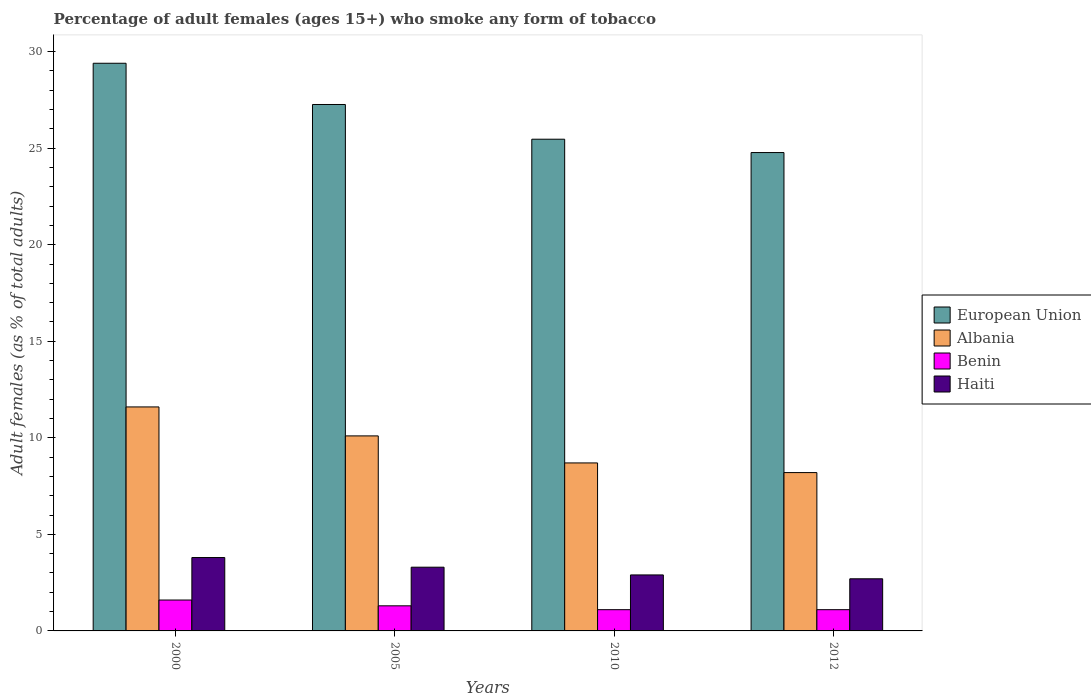Are the number of bars per tick equal to the number of legend labels?
Offer a terse response. Yes. How many bars are there on the 2nd tick from the left?
Ensure brevity in your answer.  4. What is the label of the 3rd group of bars from the left?
Offer a terse response. 2010. In how many cases, is the number of bars for a given year not equal to the number of legend labels?
Provide a short and direct response. 0. Across all years, what is the minimum percentage of adult females who smoke in Benin?
Your answer should be compact. 1.1. In which year was the percentage of adult females who smoke in Benin maximum?
Your answer should be compact. 2000. What is the total percentage of adult females who smoke in Benin in the graph?
Your answer should be compact. 5.1. What is the difference between the percentage of adult females who smoke in Benin in 2005 and that in 2012?
Ensure brevity in your answer.  0.2. What is the average percentage of adult females who smoke in Haiti per year?
Offer a terse response. 3.17. In the year 2012, what is the difference between the percentage of adult females who smoke in Haiti and percentage of adult females who smoke in Albania?
Your response must be concise. -5.5. In how many years, is the percentage of adult females who smoke in Benin greater than 25 %?
Give a very brief answer. 0. What is the ratio of the percentage of adult females who smoke in Haiti in 2000 to that in 2005?
Keep it short and to the point. 1.15. Is the percentage of adult females who smoke in Benin in 2005 less than that in 2010?
Your answer should be very brief. No. What is the difference between the highest and the second highest percentage of adult females who smoke in European Union?
Your answer should be very brief. 2.14. What is the difference between the highest and the lowest percentage of adult females who smoke in Haiti?
Your answer should be very brief. 1.1. Is the sum of the percentage of adult females who smoke in Albania in 2010 and 2012 greater than the maximum percentage of adult females who smoke in Haiti across all years?
Your response must be concise. Yes. What does the 3rd bar from the left in 2010 represents?
Your answer should be very brief. Benin. What does the 3rd bar from the right in 2012 represents?
Keep it short and to the point. Albania. How many bars are there?
Offer a very short reply. 16. Are all the bars in the graph horizontal?
Keep it short and to the point. No. What is the difference between two consecutive major ticks on the Y-axis?
Your response must be concise. 5. Does the graph contain any zero values?
Provide a succinct answer. No. Does the graph contain grids?
Ensure brevity in your answer.  No. How many legend labels are there?
Give a very brief answer. 4. What is the title of the graph?
Give a very brief answer. Percentage of adult females (ages 15+) who smoke any form of tobacco. What is the label or title of the X-axis?
Your answer should be compact. Years. What is the label or title of the Y-axis?
Make the answer very short. Adult females (as % of total adults). What is the Adult females (as % of total adults) of European Union in 2000?
Your answer should be very brief. 29.4. What is the Adult females (as % of total adults) in Haiti in 2000?
Keep it short and to the point. 3.8. What is the Adult females (as % of total adults) of European Union in 2005?
Your answer should be compact. 27.26. What is the Adult females (as % of total adults) in Benin in 2005?
Offer a terse response. 1.3. What is the Adult females (as % of total adults) in Haiti in 2005?
Make the answer very short. 3.3. What is the Adult females (as % of total adults) of European Union in 2010?
Keep it short and to the point. 25.46. What is the Adult females (as % of total adults) of Albania in 2010?
Ensure brevity in your answer.  8.7. What is the Adult females (as % of total adults) in Benin in 2010?
Give a very brief answer. 1.1. What is the Adult females (as % of total adults) in European Union in 2012?
Your answer should be compact. 24.77. What is the Adult females (as % of total adults) of Haiti in 2012?
Give a very brief answer. 2.7. Across all years, what is the maximum Adult females (as % of total adults) of European Union?
Give a very brief answer. 29.4. Across all years, what is the maximum Adult females (as % of total adults) of Albania?
Your response must be concise. 11.6. Across all years, what is the maximum Adult females (as % of total adults) of Haiti?
Provide a short and direct response. 3.8. Across all years, what is the minimum Adult females (as % of total adults) of European Union?
Keep it short and to the point. 24.77. Across all years, what is the minimum Adult females (as % of total adults) of Albania?
Keep it short and to the point. 8.2. Across all years, what is the minimum Adult females (as % of total adults) in Benin?
Provide a succinct answer. 1.1. What is the total Adult females (as % of total adults) in European Union in the graph?
Give a very brief answer. 106.9. What is the total Adult females (as % of total adults) in Albania in the graph?
Make the answer very short. 38.6. What is the difference between the Adult females (as % of total adults) of European Union in 2000 and that in 2005?
Your answer should be compact. 2.14. What is the difference between the Adult females (as % of total adults) of European Union in 2000 and that in 2010?
Give a very brief answer. 3.93. What is the difference between the Adult females (as % of total adults) in Haiti in 2000 and that in 2010?
Ensure brevity in your answer.  0.9. What is the difference between the Adult females (as % of total adults) of European Union in 2000 and that in 2012?
Provide a short and direct response. 4.62. What is the difference between the Adult females (as % of total adults) in Albania in 2000 and that in 2012?
Your answer should be very brief. 3.4. What is the difference between the Adult females (as % of total adults) in European Union in 2005 and that in 2010?
Offer a very short reply. 1.8. What is the difference between the Adult females (as % of total adults) of Albania in 2005 and that in 2010?
Provide a succinct answer. 1.4. What is the difference between the Adult females (as % of total adults) in Haiti in 2005 and that in 2010?
Keep it short and to the point. 0.4. What is the difference between the Adult females (as % of total adults) in European Union in 2005 and that in 2012?
Ensure brevity in your answer.  2.49. What is the difference between the Adult females (as % of total adults) of Haiti in 2005 and that in 2012?
Provide a succinct answer. 0.6. What is the difference between the Adult females (as % of total adults) of European Union in 2010 and that in 2012?
Offer a terse response. 0.69. What is the difference between the Adult females (as % of total adults) in Benin in 2010 and that in 2012?
Your response must be concise. 0. What is the difference between the Adult females (as % of total adults) in Haiti in 2010 and that in 2012?
Make the answer very short. 0.2. What is the difference between the Adult females (as % of total adults) of European Union in 2000 and the Adult females (as % of total adults) of Albania in 2005?
Your answer should be very brief. 19.3. What is the difference between the Adult females (as % of total adults) of European Union in 2000 and the Adult females (as % of total adults) of Benin in 2005?
Provide a succinct answer. 28.1. What is the difference between the Adult females (as % of total adults) of European Union in 2000 and the Adult females (as % of total adults) of Haiti in 2005?
Your answer should be compact. 26.1. What is the difference between the Adult females (as % of total adults) of Albania in 2000 and the Adult females (as % of total adults) of Benin in 2005?
Give a very brief answer. 10.3. What is the difference between the Adult females (as % of total adults) of Albania in 2000 and the Adult females (as % of total adults) of Haiti in 2005?
Your answer should be very brief. 8.3. What is the difference between the Adult females (as % of total adults) in Benin in 2000 and the Adult females (as % of total adults) in Haiti in 2005?
Ensure brevity in your answer.  -1.7. What is the difference between the Adult females (as % of total adults) of European Union in 2000 and the Adult females (as % of total adults) of Albania in 2010?
Give a very brief answer. 20.7. What is the difference between the Adult females (as % of total adults) of European Union in 2000 and the Adult females (as % of total adults) of Benin in 2010?
Provide a short and direct response. 28.3. What is the difference between the Adult females (as % of total adults) in European Union in 2000 and the Adult females (as % of total adults) in Haiti in 2010?
Your answer should be compact. 26.5. What is the difference between the Adult females (as % of total adults) in Albania in 2000 and the Adult females (as % of total adults) in Benin in 2010?
Ensure brevity in your answer.  10.5. What is the difference between the Adult females (as % of total adults) of Albania in 2000 and the Adult females (as % of total adults) of Haiti in 2010?
Provide a short and direct response. 8.7. What is the difference between the Adult females (as % of total adults) of European Union in 2000 and the Adult females (as % of total adults) of Albania in 2012?
Provide a succinct answer. 21.2. What is the difference between the Adult females (as % of total adults) in European Union in 2000 and the Adult females (as % of total adults) in Benin in 2012?
Provide a succinct answer. 28.3. What is the difference between the Adult females (as % of total adults) in European Union in 2000 and the Adult females (as % of total adults) in Haiti in 2012?
Provide a succinct answer. 26.7. What is the difference between the Adult females (as % of total adults) of Benin in 2000 and the Adult females (as % of total adults) of Haiti in 2012?
Give a very brief answer. -1.1. What is the difference between the Adult females (as % of total adults) of European Union in 2005 and the Adult females (as % of total adults) of Albania in 2010?
Your answer should be very brief. 18.56. What is the difference between the Adult females (as % of total adults) in European Union in 2005 and the Adult females (as % of total adults) in Benin in 2010?
Provide a short and direct response. 26.16. What is the difference between the Adult females (as % of total adults) of European Union in 2005 and the Adult females (as % of total adults) of Haiti in 2010?
Ensure brevity in your answer.  24.36. What is the difference between the Adult females (as % of total adults) of Benin in 2005 and the Adult females (as % of total adults) of Haiti in 2010?
Ensure brevity in your answer.  -1.6. What is the difference between the Adult females (as % of total adults) in European Union in 2005 and the Adult females (as % of total adults) in Albania in 2012?
Your response must be concise. 19.06. What is the difference between the Adult females (as % of total adults) of European Union in 2005 and the Adult females (as % of total adults) of Benin in 2012?
Make the answer very short. 26.16. What is the difference between the Adult females (as % of total adults) in European Union in 2005 and the Adult females (as % of total adults) in Haiti in 2012?
Your answer should be compact. 24.56. What is the difference between the Adult females (as % of total adults) of Benin in 2005 and the Adult females (as % of total adults) of Haiti in 2012?
Provide a short and direct response. -1.4. What is the difference between the Adult females (as % of total adults) of European Union in 2010 and the Adult females (as % of total adults) of Albania in 2012?
Provide a short and direct response. 17.26. What is the difference between the Adult females (as % of total adults) of European Union in 2010 and the Adult females (as % of total adults) of Benin in 2012?
Your answer should be very brief. 24.36. What is the difference between the Adult females (as % of total adults) of European Union in 2010 and the Adult females (as % of total adults) of Haiti in 2012?
Keep it short and to the point. 22.76. What is the difference between the Adult females (as % of total adults) in Albania in 2010 and the Adult females (as % of total adults) in Haiti in 2012?
Ensure brevity in your answer.  6. What is the average Adult females (as % of total adults) of European Union per year?
Keep it short and to the point. 26.72. What is the average Adult females (as % of total adults) in Albania per year?
Your response must be concise. 9.65. What is the average Adult females (as % of total adults) of Benin per year?
Your answer should be compact. 1.27. What is the average Adult females (as % of total adults) of Haiti per year?
Your answer should be very brief. 3.17. In the year 2000, what is the difference between the Adult females (as % of total adults) of European Union and Adult females (as % of total adults) of Albania?
Your response must be concise. 17.8. In the year 2000, what is the difference between the Adult females (as % of total adults) of European Union and Adult females (as % of total adults) of Benin?
Make the answer very short. 27.8. In the year 2000, what is the difference between the Adult females (as % of total adults) of European Union and Adult females (as % of total adults) of Haiti?
Make the answer very short. 25.6. In the year 2000, what is the difference between the Adult females (as % of total adults) in Albania and Adult females (as % of total adults) in Haiti?
Offer a very short reply. 7.8. In the year 2000, what is the difference between the Adult females (as % of total adults) in Benin and Adult females (as % of total adults) in Haiti?
Provide a succinct answer. -2.2. In the year 2005, what is the difference between the Adult females (as % of total adults) in European Union and Adult females (as % of total adults) in Albania?
Your answer should be compact. 17.16. In the year 2005, what is the difference between the Adult females (as % of total adults) in European Union and Adult females (as % of total adults) in Benin?
Make the answer very short. 25.96. In the year 2005, what is the difference between the Adult females (as % of total adults) of European Union and Adult females (as % of total adults) of Haiti?
Keep it short and to the point. 23.96. In the year 2005, what is the difference between the Adult females (as % of total adults) of Albania and Adult females (as % of total adults) of Benin?
Give a very brief answer. 8.8. In the year 2010, what is the difference between the Adult females (as % of total adults) of European Union and Adult females (as % of total adults) of Albania?
Give a very brief answer. 16.76. In the year 2010, what is the difference between the Adult females (as % of total adults) in European Union and Adult females (as % of total adults) in Benin?
Make the answer very short. 24.36. In the year 2010, what is the difference between the Adult females (as % of total adults) of European Union and Adult females (as % of total adults) of Haiti?
Keep it short and to the point. 22.56. In the year 2010, what is the difference between the Adult females (as % of total adults) of Albania and Adult females (as % of total adults) of Benin?
Your answer should be compact. 7.6. In the year 2010, what is the difference between the Adult females (as % of total adults) in Albania and Adult females (as % of total adults) in Haiti?
Offer a very short reply. 5.8. In the year 2012, what is the difference between the Adult females (as % of total adults) in European Union and Adult females (as % of total adults) in Albania?
Offer a terse response. 16.57. In the year 2012, what is the difference between the Adult females (as % of total adults) of European Union and Adult females (as % of total adults) of Benin?
Keep it short and to the point. 23.67. In the year 2012, what is the difference between the Adult females (as % of total adults) in European Union and Adult females (as % of total adults) in Haiti?
Give a very brief answer. 22.07. In the year 2012, what is the difference between the Adult females (as % of total adults) in Benin and Adult females (as % of total adults) in Haiti?
Offer a very short reply. -1.6. What is the ratio of the Adult females (as % of total adults) of European Union in 2000 to that in 2005?
Give a very brief answer. 1.08. What is the ratio of the Adult females (as % of total adults) of Albania in 2000 to that in 2005?
Provide a succinct answer. 1.15. What is the ratio of the Adult females (as % of total adults) in Benin in 2000 to that in 2005?
Provide a short and direct response. 1.23. What is the ratio of the Adult females (as % of total adults) of Haiti in 2000 to that in 2005?
Keep it short and to the point. 1.15. What is the ratio of the Adult females (as % of total adults) of European Union in 2000 to that in 2010?
Give a very brief answer. 1.15. What is the ratio of the Adult females (as % of total adults) of Benin in 2000 to that in 2010?
Your response must be concise. 1.45. What is the ratio of the Adult females (as % of total adults) of Haiti in 2000 to that in 2010?
Keep it short and to the point. 1.31. What is the ratio of the Adult females (as % of total adults) in European Union in 2000 to that in 2012?
Provide a succinct answer. 1.19. What is the ratio of the Adult females (as % of total adults) of Albania in 2000 to that in 2012?
Your answer should be very brief. 1.41. What is the ratio of the Adult females (as % of total adults) in Benin in 2000 to that in 2012?
Provide a succinct answer. 1.45. What is the ratio of the Adult females (as % of total adults) of Haiti in 2000 to that in 2012?
Ensure brevity in your answer.  1.41. What is the ratio of the Adult females (as % of total adults) in European Union in 2005 to that in 2010?
Provide a succinct answer. 1.07. What is the ratio of the Adult females (as % of total adults) in Albania in 2005 to that in 2010?
Give a very brief answer. 1.16. What is the ratio of the Adult females (as % of total adults) in Benin in 2005 to that in 2010?
Make the answer very short. 1.18. What is the ratio of the Adult females (as % of total adults) in Haiti in 2005 to that in 2010?
Offer a very short reply. 1.14. What is the ratio of the Adult females (as % of total adults) of European Union in 2005 to that in 2012?
Offer a terse response. 1.1. What is the ratio of the Adult females (as % of total adults) in Albania in 2005 to that in 2012?
Provide a short and direct response. 1.23. What is the ratio of the Adult females (as % of total adults) of Benin in 2005 to that in 2012?
Ensure brevity in your answer.  1.18. What is the ratio of the Adult females (as % of total adults) in Haiti in 2005 to that in 2012?
Your response must be concise. 1.22. What is the ratio of the Adult females (as % of total adults) in European Union in 2010 to that in 2012?
Offer a terse response. 1.03. What is the ratio of the Adult females (as % of total adults) in Albania in 2010 to that in 2012?
Your answer should be very brief. 1.06. What is the ratio of the Adult females (as % of total adults) of Benin in 2010 to that in 2012?
Make the answer very short. 1. What is the ratio of the Adult females (as % of total adults) in Haiti in 2010 to that in 2012?
Offer a very short reply. 1.07. What is the difference between the highest and the second highest Adult females (as % of total adults) of European Union?
Provide a short and direct response. 2.14. What is the difference between the highest and the second highest Adult females (as % of total adults) in Albania?
Keep it short and to the point. 1.5. What is the difference between the highest and the second highest Adult females (as % of total adults) in Haiti?
Your answer should be very brief. 0.5. What is the difference between the highest and the lowest Adult females (as % of total adults) in European Union?
Your response must be concise. 4.62. What is the difference between the highest and the lowest Adult females (as % of total adults) of Benin?
Make the answer very short. 0.5. 